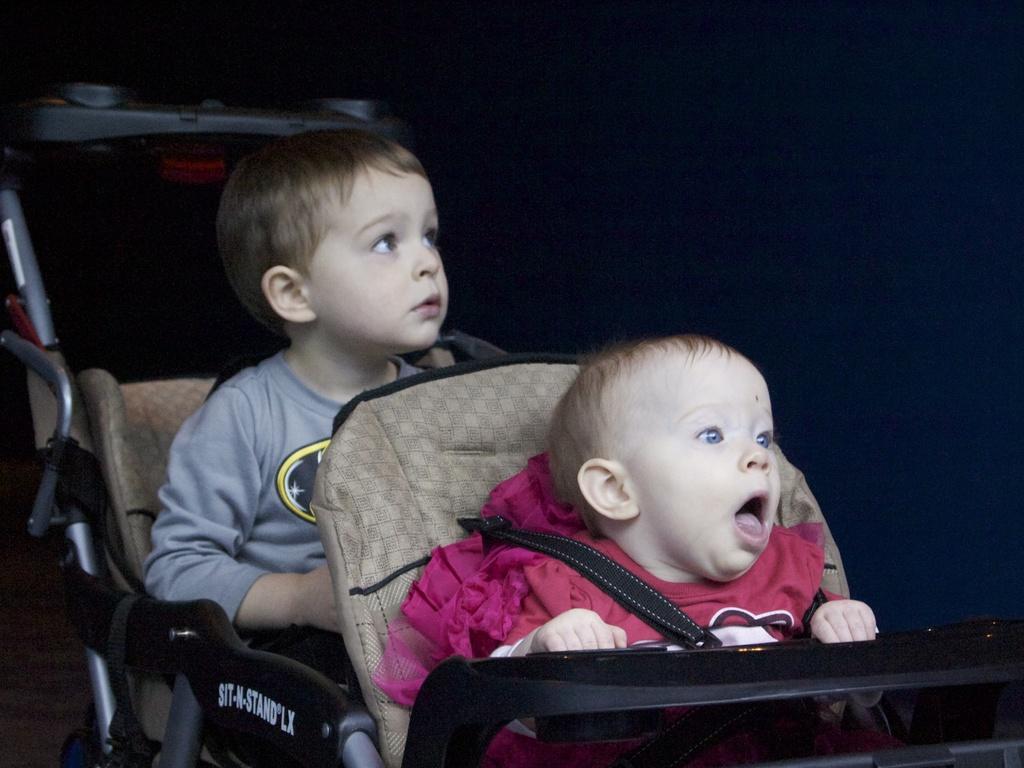How would you summarize this image in a sentence or two? In this picture there are two people sitting on the vehicle. At the back it looks like a wall and there is text on the vehicle. At the bottom it looks like a floor. 